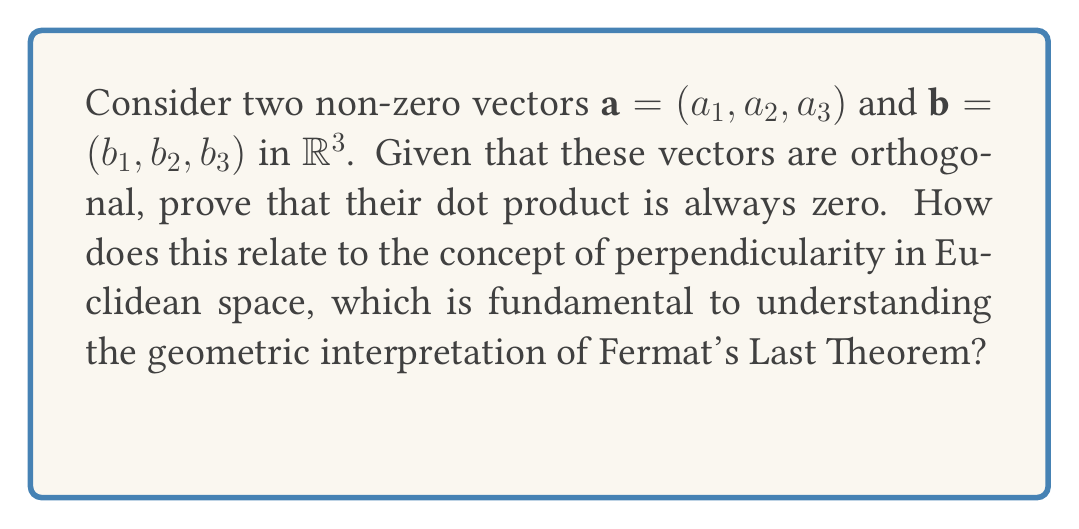Give your solution to this math problem. Let's prove this step-by-step:

1) The dot product of two vectors $\mathbf{a} = (a_1, a_2, a_3)$ and $\mathbf{b} = (b_1, b_2, b_3)$ is defined as:

   $$\mathbf{a} \cdot \mathbf{b} = a_1b_1 + a_2b_2 + a_3b_3$$

2) Orthogonal vectors are perpendicular to each other. In $\mathbb{R}^3$, this means that the angle between them is 90°.

3) The dot product of two vectors can also be expressed in terms of the angle $\theta$ between them:

   $$\mathbf{a} \cdot \mathbf{b} = |\mathbf{a}||\mathbf{b}|\cos\theta$$

   where $|\mathbf{a}|$ and $|\mathbf{b}|$ are the magnitudes of the vectors.

4) If the vectors are orthogonal, $\theta = 90°$. We know that $\cos 90° = 0$.

5) Therefore, for orthogonal vectors:

   $$\mathbf{a} \cdot \mathbf{b} = |\mathbf{a}||\mathbf{b}|\cos 90° = |\mathbf{a}||\mathbf{b}| \cdot 0 = 0$$

6) This proves that the dot product of orthogonal vectors is always zero.

Relation to Fermat's Last Theorem:
The concept of orthogonality in Euclidean space is crucial in understanding the geometric interpretation of Fermat's Last Theorem. Fermat's Last Theorem states that no three positive integers $a$, $b$, and $c$ can satisfy the equation $a^n + b^n = c^n$ for any integer value of $n$ greater than 2.

For $n = 2$, this equation represents the Pythagorean theorem, which relates to right triangles in Euclidean space. The sides of a right triangle are orthogonal, just like our vectors. As $n$ increases beyond 2, the geometric interpretation becomes more complex, but the fundamental concept of orthogonality in higher-dimensional spaces remains relevant to understanding the theorem's implications.
Answer: The dot product of orthogonal vectors is always zero: $\mathbf{a} \cdot \mathbf{b} = 0$. 